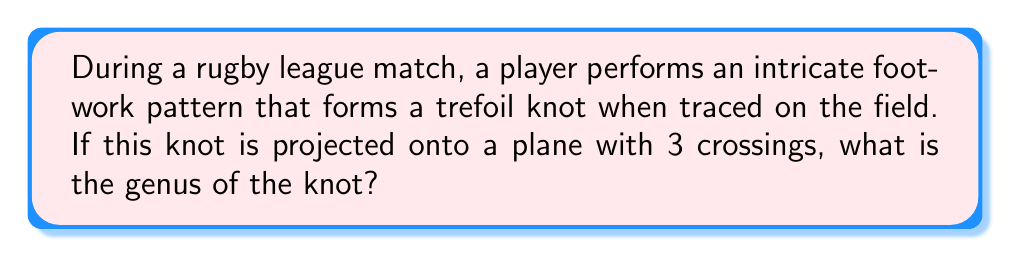What is the answer to this math problem? To determine the genus of the knot formed by the player's footwork, we'll follow these steps:

1. Identify the knot: The question states it's a trefoil knot.

2. Recall the formula for the genus of a knot:
   $$g = \frac{1}{2}(c - n + 1)$$
   where $g$ is the genus, $c$ is the number of crossings, and $n$ is the number of components.

3. Determine the values:
   - $c = 3$ (given in the question)
   - $n = 1$ (trefoil knot is a single component)

4. Substitute these values into the formula:
   $$g = \frac{1}{2}(3 - 1 + 1)$$

5. Simplify:
   $$g = \frac{1}{2}(3) = \frac{3}{2}$$

6. Since genus must be a non-negative integer, we round up to the nearest whole number:
   $$g = 1$$

Therefore, the genus of the trefoil knot formed by the player's footwork is 1.
Answer: 1 